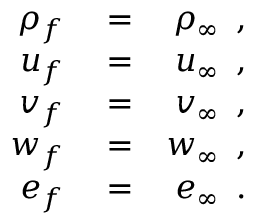<formula> <loc_0><loc_0><loc_500><loc_500>\begin{array} { r l r } { \rho _ { f } } & = } & { \rho _ { \infty } \, , } \\ { u _ { f } } & = } & { u _ { \infty } \, , } \\ { v _ { f } } & = } & { v _ { \infty } \, , } \\ { w _ { f } } & = } & { w _ { \infty } \, , } \\ { e _ { f } } & = } & { e _ { \infty } \, . } \end{array}</formula> 